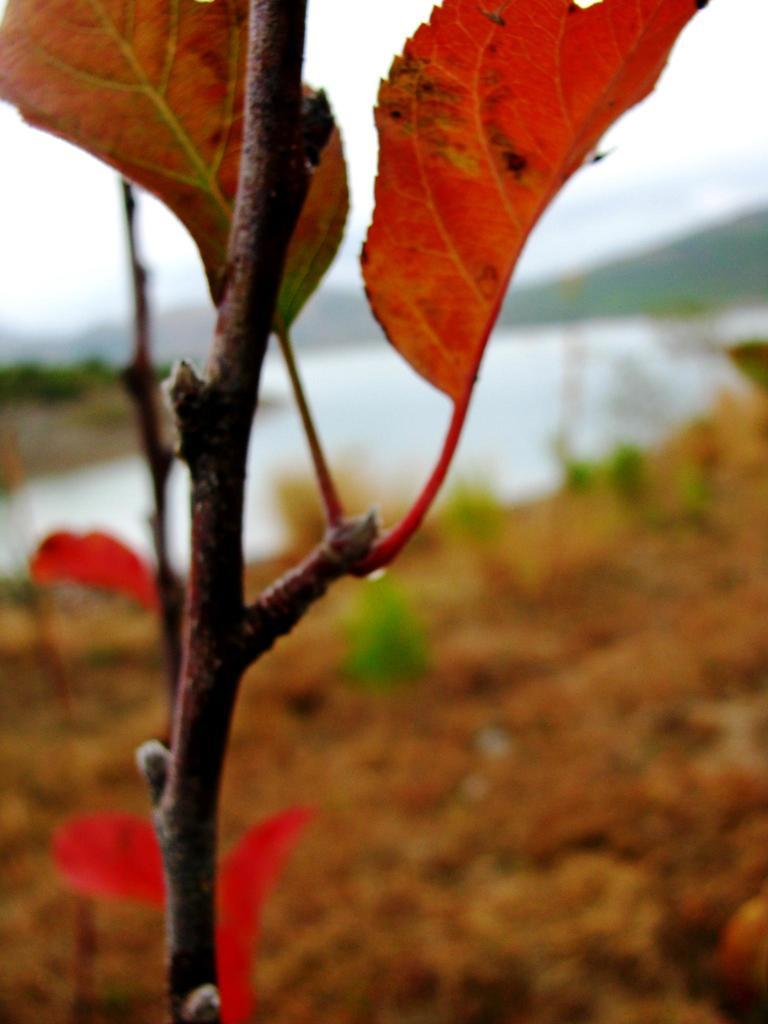What is the main subject of the image? The main subject of the image is a stem of a plant. How many leaves are visible in the image? There are two leaves in the image. Can you describe the background of the image? The background of the image is blurred. What type of natural elements can be seen in the image? There is sand and water visible in the image. What type of tent can be seen in the image? There is no tent present in the image. How does the plant provide pleasure in the image? The image does not depict any emotions or experiences related to pleasure; it simply shows a stem of a plant with two leaves. 